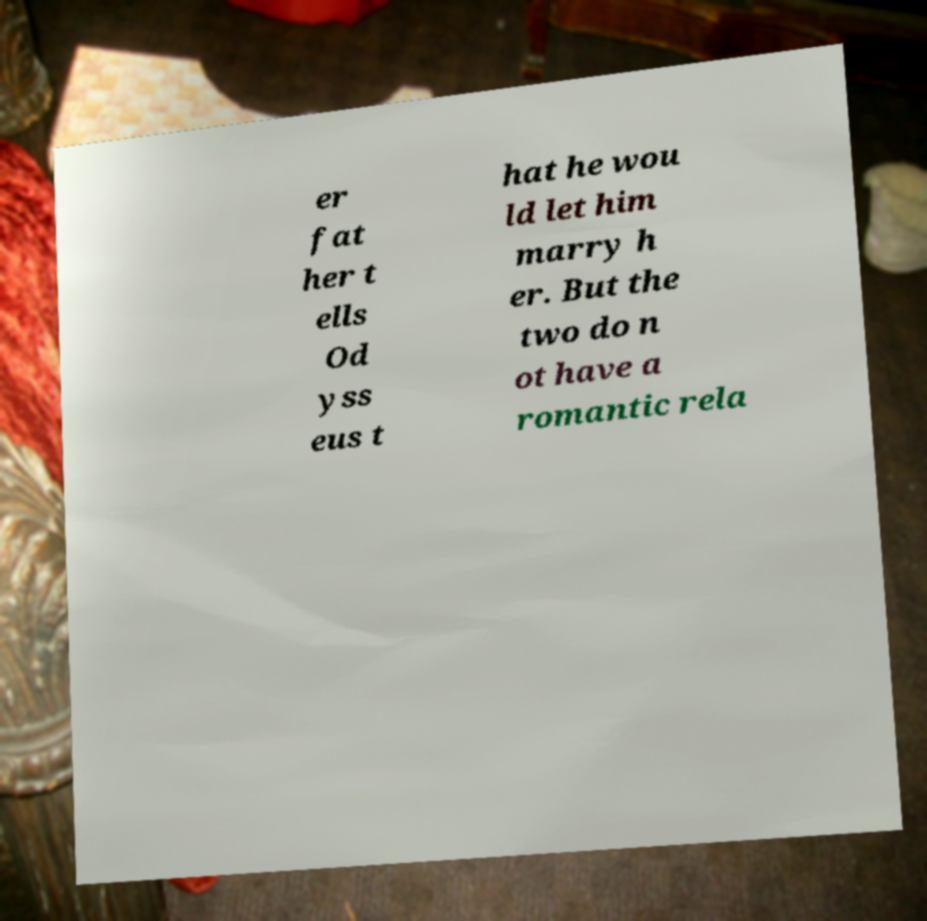Please identify and transcribe the text found in this image. er fat her t ells Od yss eus t hat he wou ld let him marry h er. But the two do n ot have a romantic rela 